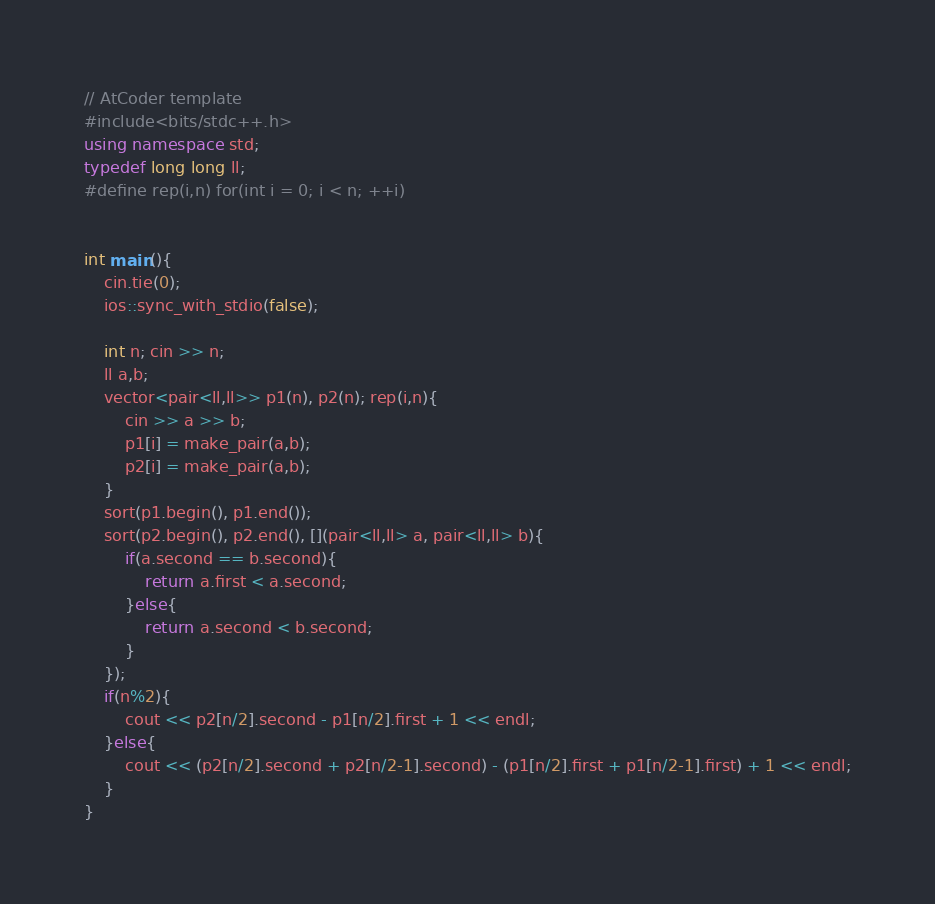Convert code to text. <code><loc_0><loc_0><loc_500><loc_500><_C++_>// AtCoder template
#include<bits/stdc++.h>
using namespace std;
typedef long long ll;
#define rep(i,n) for(int i = 0; i < n; ++i)


int main(){
    cin.tie(0);
    ios::sync_with_stdio(false);

    int n; cin >> n;
    ll a,b;
    vector<pair<ll,ll>> p1(n), p2(n); rep(i,n){
        cin >> a >> b;
        p1[i] = make_pair(a,b);
        p2[i] = make_pair(a,b);
    }
    sort(p1.begin(), p1.end());
    sort(p2.begin(), p2.end(), [](pair<ll,ll> a, pair<ll,ll> b){
        if(a.second == b.second){
            return a.first < a.second;
        }else{
            return a.second < b.second;
        }
    });
    if(n%2){
        cout << p2[n/2].second - p1[n/2].first + 1 << endl;
    }else{
        cout << (p2[n/2].second + p2[n/2-1].second) - (p1[n/2].first + p1[n/2-1].first) + 1 << endl;
    }
}</code> 